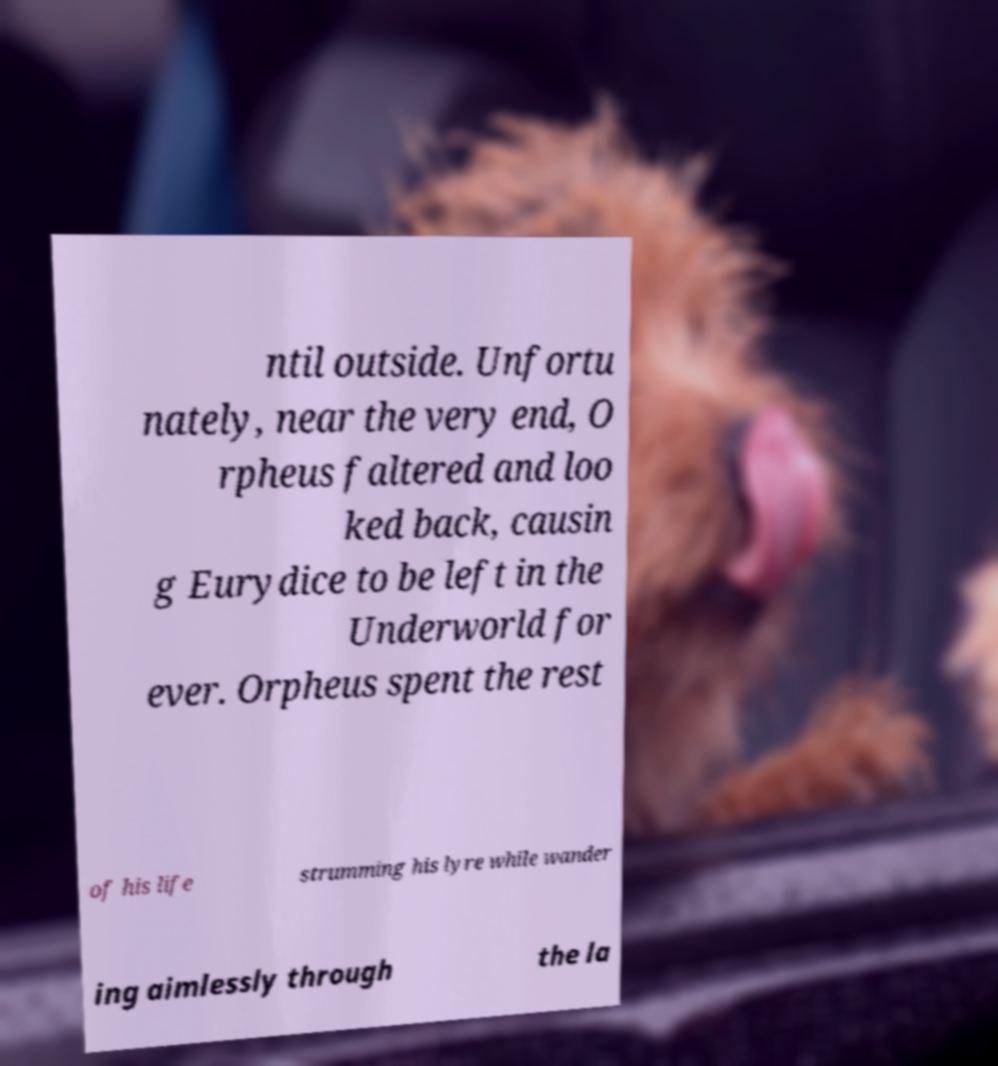Please read and relay the text visible in this image. What does it say? ntil outside. Unfortu nately, near the very end, O rpheus faltered and loo ked back, causin g Eurydice to be left in the Underworld for ever. Orpheus spent the rest of his life strumming his lyre while wander ing aimlessly through the la 